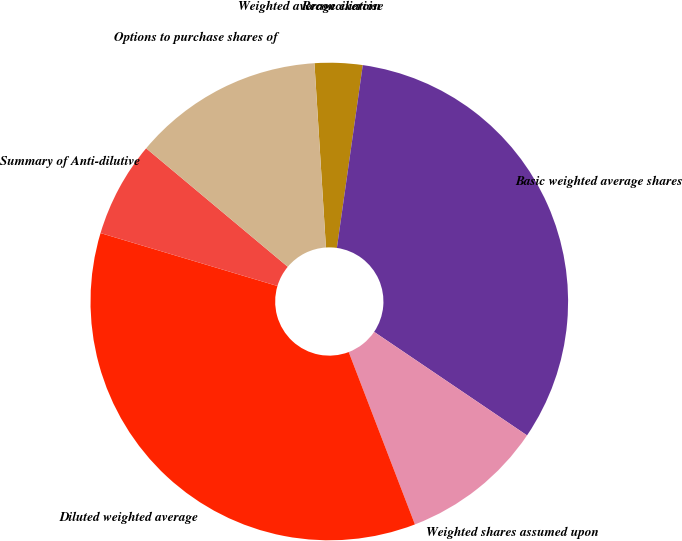Convert chart to OTSL. <chart><loc_0><loc_0><loc_500><loc_500><pie_chart><fcel>Reconciliation<fcel>Basic weighted average shares<fcel>Weighted shares assumed upon<fcel>Diluted weighted average<fcel>Summary of Anti-dilutive<fcel>Options to purchase shares of<fcel>Weighted average exercise<nl><fcel>3.23%<fcel>32.23%<fcel>9.69%<fcel>35.46%<fcel>6.46%<fcel>12.92%<fcel>0.0%<nl></chart> 